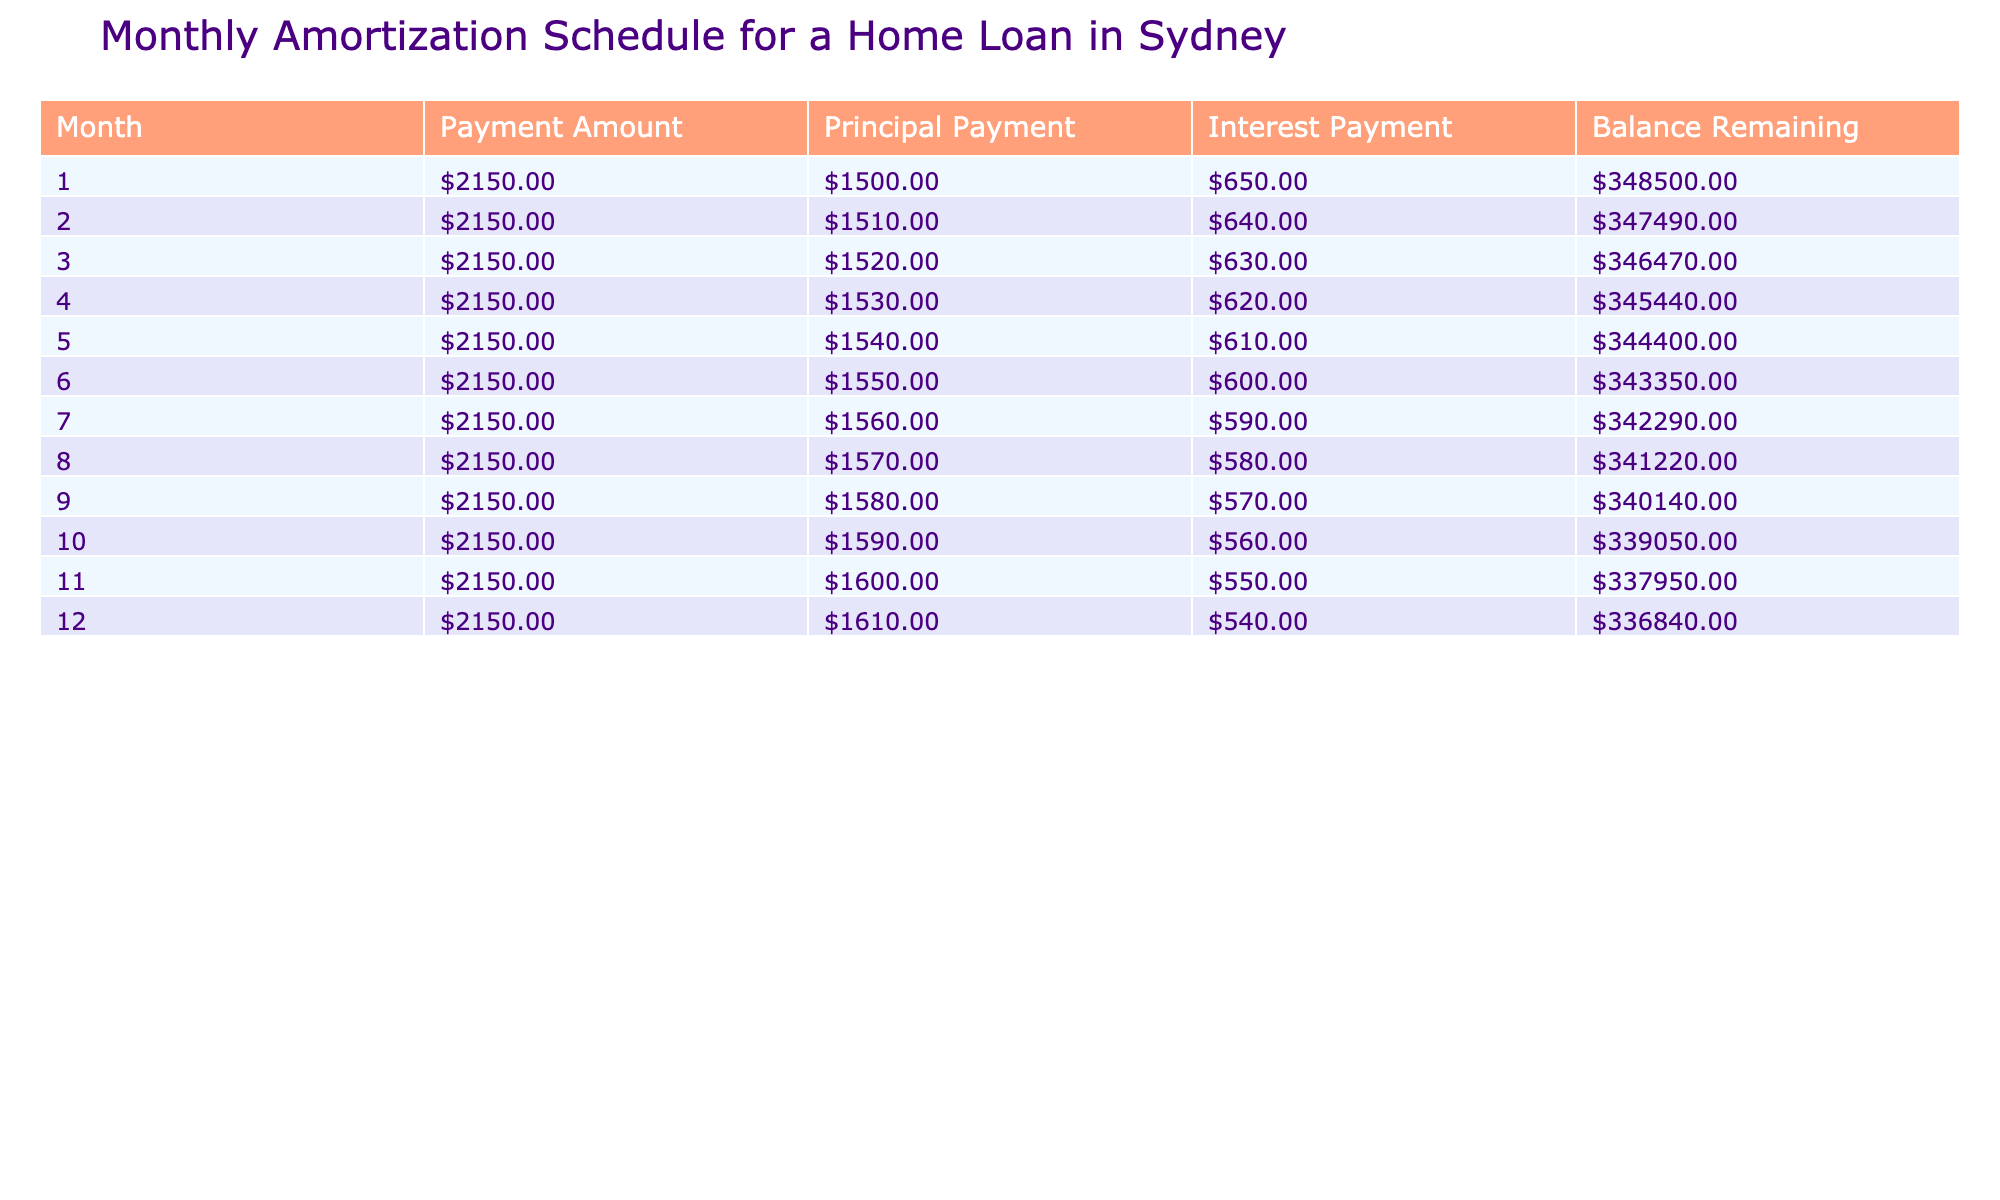What is the payment amount for the first month? The payment amount is explicitly listed in the first row of the table under the "Payment Amount" column.
Answer: 2150.00 What is the principal payment for the third month? The principal payment is found in the third row of the table under the "Principal Payment" column.
Answer: 1520.00 Is the interest payment decreasing every month? The interest payments are listed in the table, and by examining the "Interest Payment" column, I can see that the values decrease from 650.00 in the first month to 540.00 in the twelfth month.
Answer: Yes What is the total principal payment made from month 1 to month 6? To find the total principal payment for the first six months, I add the principal payments from those months: 1500.00 + 1510.00 + 1520.00 + 1530.00 + 1540.00 + 1550.00 = 9180.00.
Answer: 9180.00 How much has the balance remaining decreased by the end of the first year (month 12)? To calculate the decrease in the balance, I subtract the balance remaining at the end of month 12 (336840.00) from the initial balance (350000.00): 350000.00 - 336840.00 = 11660.00.
Answer: 11660.00 What is the average interest payment from month 1 to month 12? First, I sum the interest payments for the twelve months: (650.00 + 640.00 + 630.00 + 620.00 + 610.00 + 600.00 + 590.00 + 580.00 + 570.00 + 560.00 + 550.00 + 540.00) = 7040.00. Then, I divide by the number of months: 7040.00 / 12 = 586.67.
Answer: 586.67 What is the total payment made over the first 12 months? First, I find the total payment amount for each of the twelve months. Since the payment amount is constant at 2150.00, I multiply this by 12 months: 2150.00 * 12 = 25800.00.
Answer: 25800.00 Was the payment made in the tenth month greater than the payment made in the fifth month? Both the payments in the tenth month and the fifth month are equal at 2150.00, so comparing the two shows they are the same.
Answer: No What is the total interest paid over the first year? I need to sum all the interest payments over the twelve months: 650.00 + 640.00 + 630.00 + 620.00 + 610.00 + 600.00 + 590.00 + 580.00 + 570.00 + 560.00 + 550.00 + 540.00 = 7040.00. Thus, the total interest paid over the first year is 7040.00.
Answer: 7040.00 